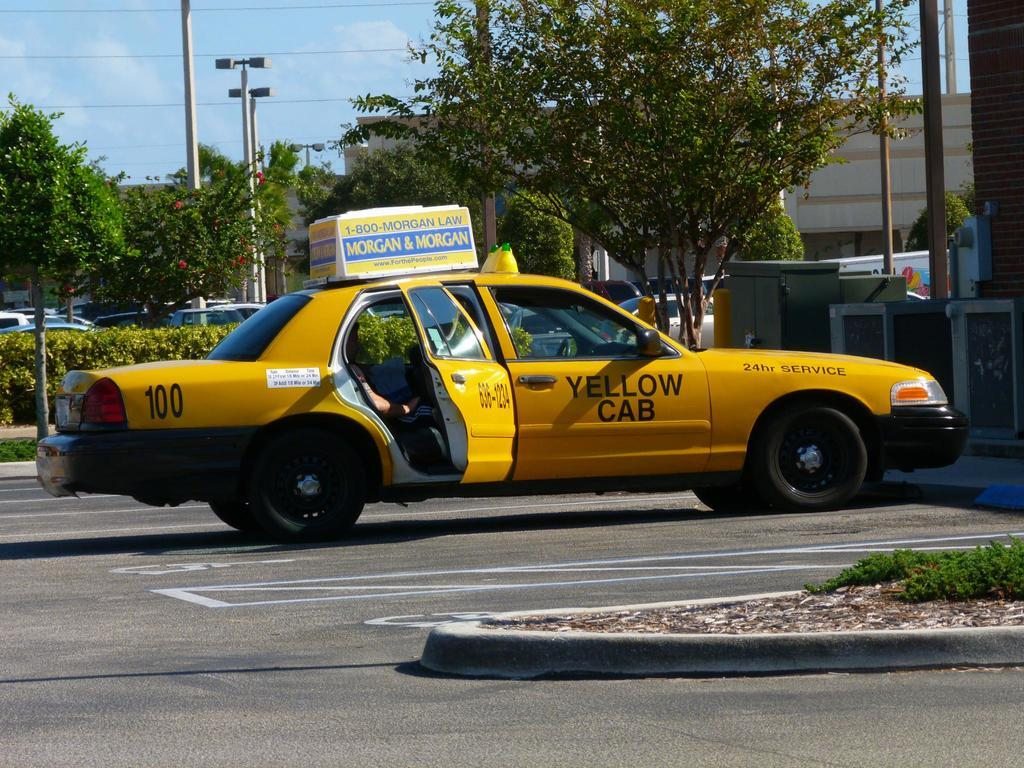<image>
Provide a brief description of the given image. A yellow cab can be seen with an advertisment for Morgan & Morgan. 